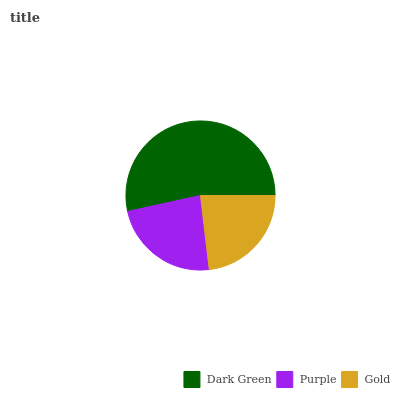Is Gold the minimum?
Answer yes or no. Yes. Is Dark Green the maximum?
Answer yes or no. Yes. Is Purple the minimum?
Answer yes or no. No. Is Purple the maximum?
Answer yes or no. No. Is Dark Green greater than Purple?
Answer yes or no. Yes. Is Purple less than Dark Green?
Answer yes or no. Yes. Is Purple greater than Dark Green?
Answer yes or no. No. Is Dark Green less than Purple?
Answer yes or no. No. Is Purple the high median?
Answer yes or no. Yes. Is Purple the low median?
Answer yes or no. Yes. Is Gold the high median?
Answer yes or no. No. Is Gold the low median?
Answer yes or no. No. 